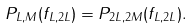<formula> <loc_0><loc_0><loc_500><loc_500>P _ { L , M } ( f _ { L , 2 L } ) = P _ { 2 L , 2 M } ( f _ { L , 2 L } ) .</formula> 